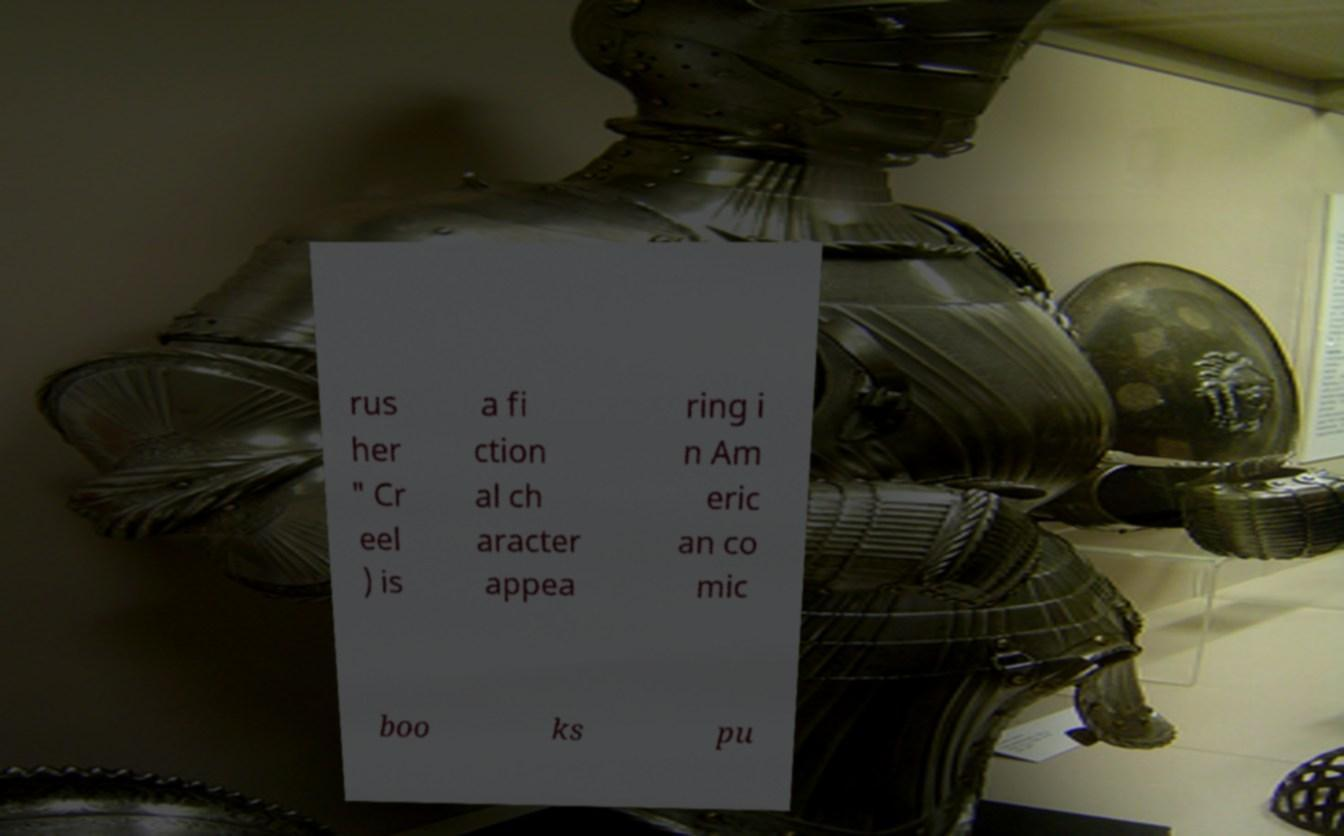Could you assist in decoding the text presented in this image and type it out clearly? rus her " Cr eel ) is a fi ction al ch aracter appea ring i n Am eric an co mic boo ks pu 